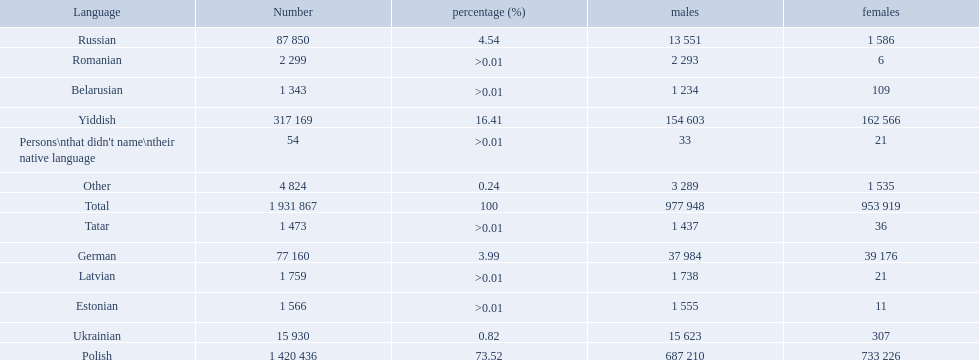What were all the languages? Polish, Yiddish, Russian, German, Ukrainian, Romanian, Latvian, Estonian, Tatar, Belarusian, Other, Persons\nthat didn't name\ntheir native language. For these, how many people spoke them? 1 420 436, 317 169, 87 850, 77 160, 15 930, 2 299, 1 759, 1 566, 1 473, 1 343, 4 824, 54. Of these, which is the largest number of speakers? 1 420 436. Which language corresponds to this number? Polish. 